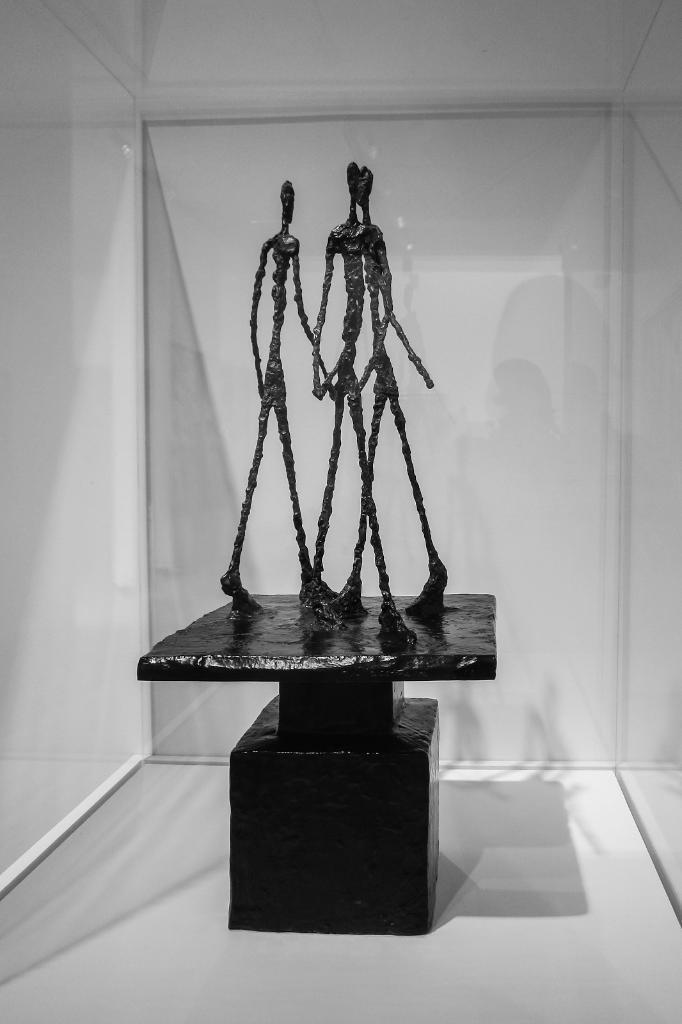Please provide a concise description of this image. We can see statues on the surface and we can see glass. Background it is white color. 